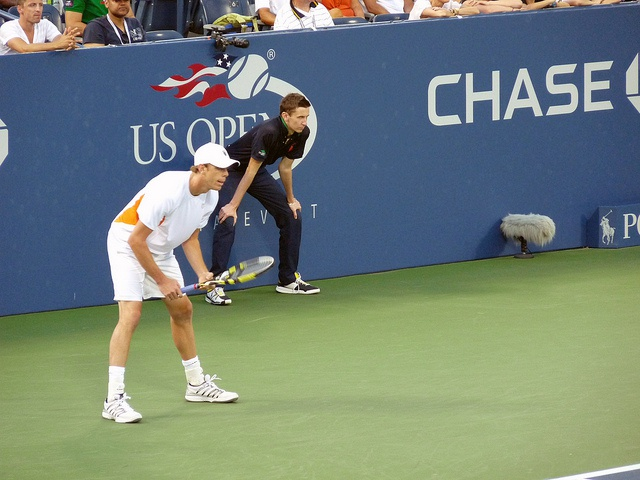Describe the objects in this image and their specific colors. I can see people in maroon, white, tan, gray, and darkgray tones, people in maroon, black, gray, blue, and lightgray tones, people in maroon, white, tan, and salmon tones, people in maroon, black, gray, and brown tones, and people in maroon, white, salmon, tan, and black tones in this image. 